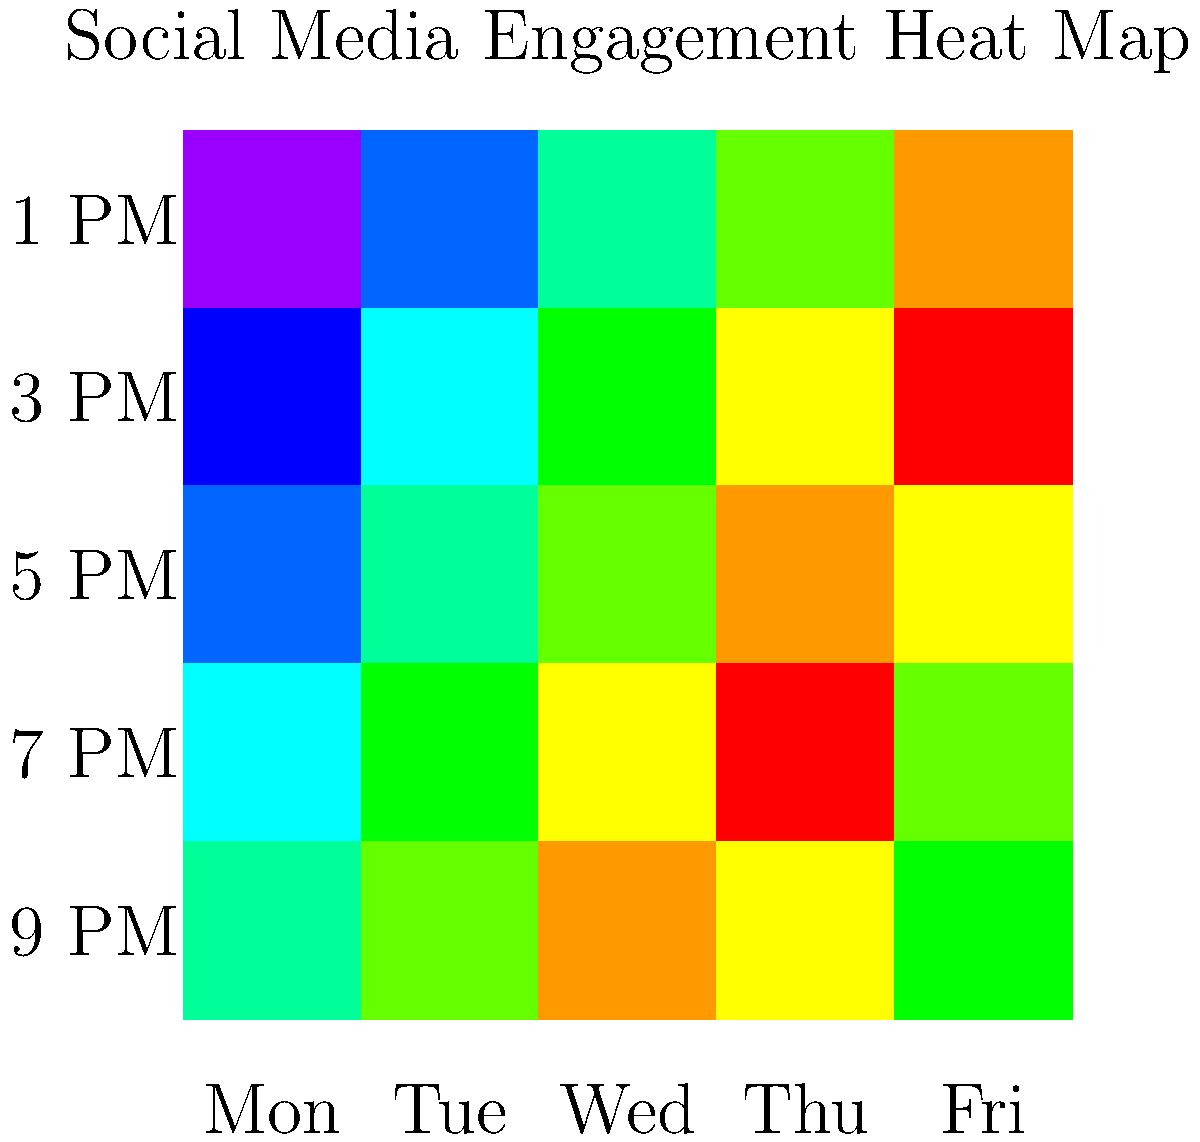As a TV showrunner, you're analyzing social media engagement for your latest series. The heat map above shows engagement levels throughout the week. Which day and time slot combination consistently shows the highest engagement, potentially indicating the best time to release teasers or engage with fans? To determine the day and time slot with the highest engagement, we need to analyze the heat map:

1. The heat map uses color intensity to represent engagement levels, with darker colors indicating higher engagement.

2. Examine each day (column) and time slot (row) combination:
   - Monday: Gradual increase from light to dark
   - Tuesday: Similar pattern to Monday, slightly darker
   - Wednesday: Darker overall, especially in later time slots
   - Thursday: Darkest overall, particularly in later time slots
   - Friday: Dark in earlier time slots, lightens towards the end

3. The darkest square, representing the highest engagement, is located in the Thursday column and the second row from the bottom.

4. Reading the labels, we can see that this corresponds to Thursday at 7 PM.

5. This time slot is consistently dark across multiple days, indicating a pattern of high engagement during evening hours.

Therefore, Thursday at 7 PM shows the highest and most consistent engagement, making it the ideal time for releasing teasers or engaging with fans.
Answer: Thursday at 7 PM 